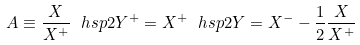<formula> <loc_0><loc_0><loc_500><loc_500>A \equiv \frac { X } { X ^ { + } } \ h s p 2 Y ^ { + } = X ^ { + } \ h s p 2 Y = X ^ { - } - \frac { 1 } { 2 } \frac { X } { X ^ { + } }</formula> 